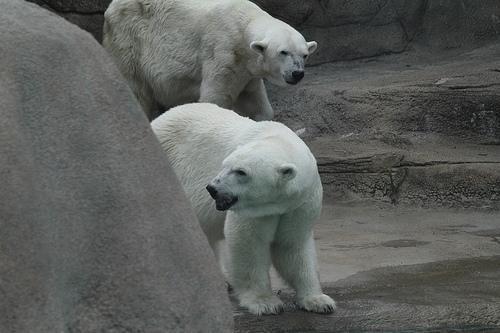How many are in the image?
Give a very brief answer. 2. How many polar bears are in the front of the image?
Give a very brief answer. 1. 